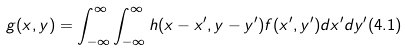<formula> <loc_0><loc_0><loc_500><loc_500>g ( x , y ) = \int _ { - \infty } ^ { \infty } \int _ { - \infty } ^ { \infty } h ( x - x ^ { \prime } , y - y ^ { \prime } ) f ( x ^ { \prime } , y ^ { \prime } ) d x ^ { \prime } d y ^ { \prime } ( 4 . 1 )</formula> 